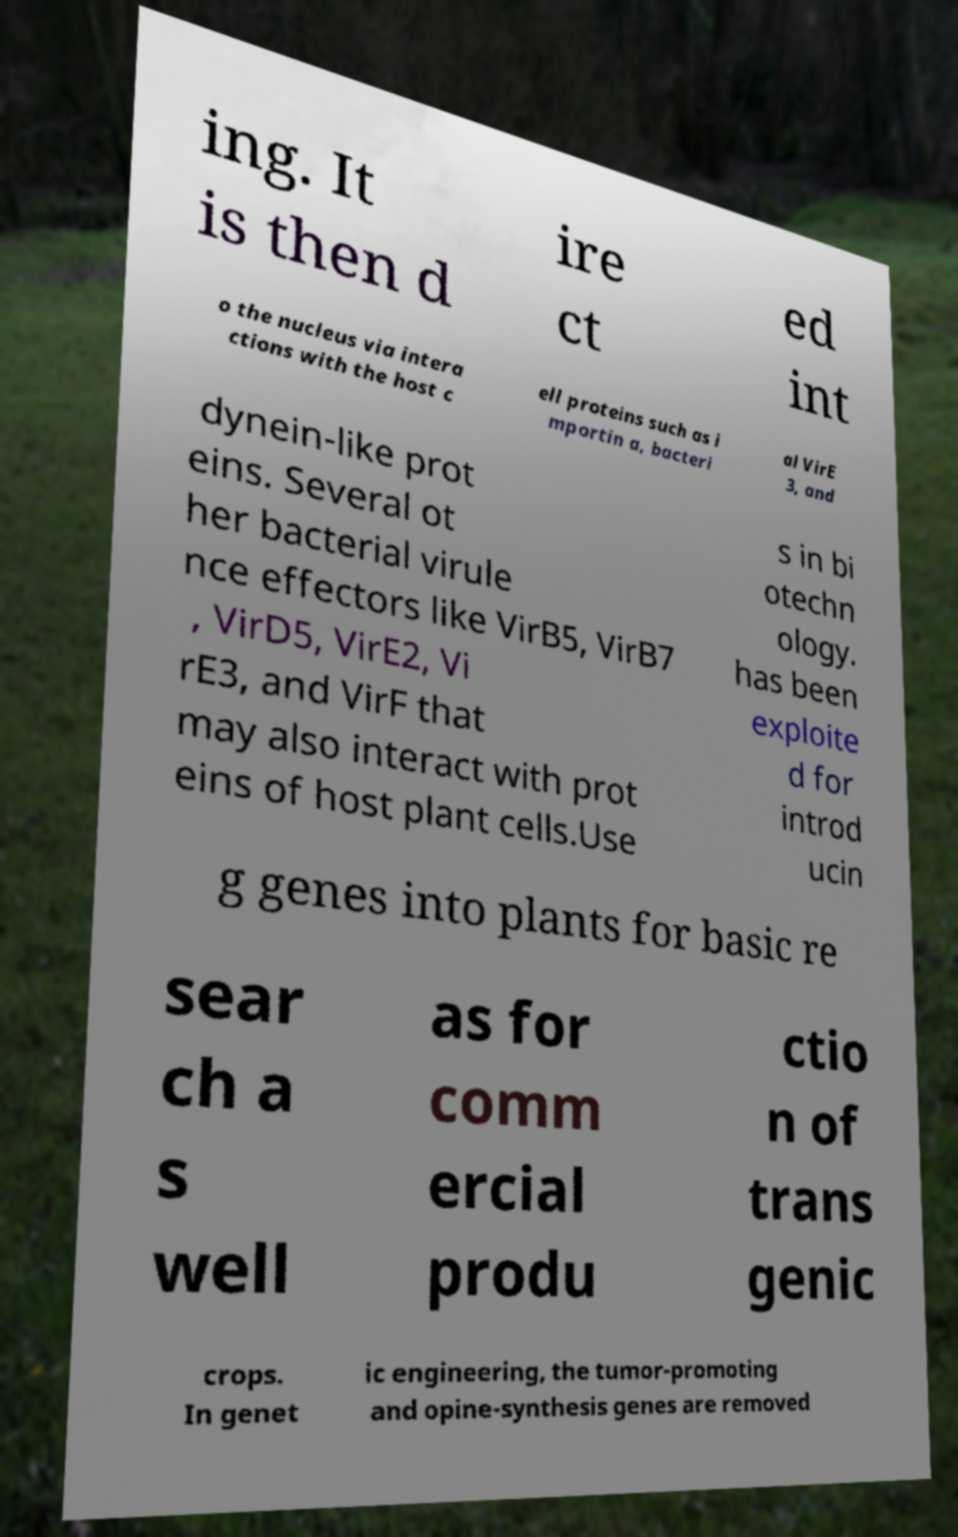What messages or text are displayed in this image? I need them in a readable, typed format. ing. It is then d ire ct ed int o the nucleus via intera ctions with the host c ell proteins such as i mportin a, bacteri al VirE 3, and dynein-like prot eins. Several ot her bacterial virule nce effectors like VirB5, VirB7 , VirD5, VirE2, Vi rE3, and VirF that may also interact with prot eins of host plant cells.Use s in bi otechn ology. has been exploite d for introd ucin g genes into plants for basic re sear ch a s well as for comm ercial produ ctio n of trans genic crops. In genet ic engineering, the tumor-promoting and opine-synthesis genes are removed 